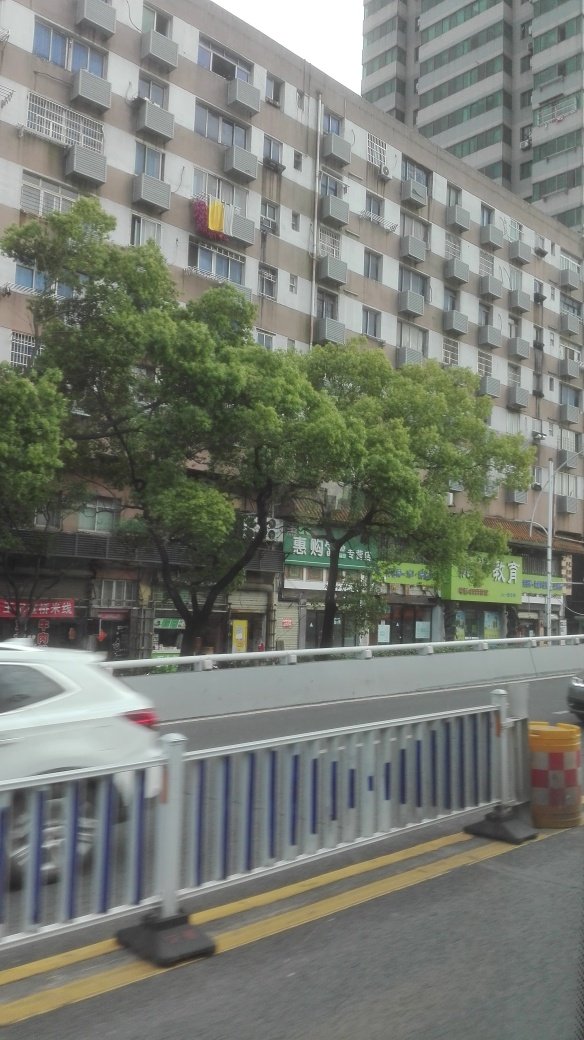Is the lighting sufficient in the image?
A. natural
B. excessive
C. yes The lighting in the image appears natural and provides sufficient visibility without being excessive. It's well-balanced, making the details of the cityscape, trees, and buildings clearly visible. 